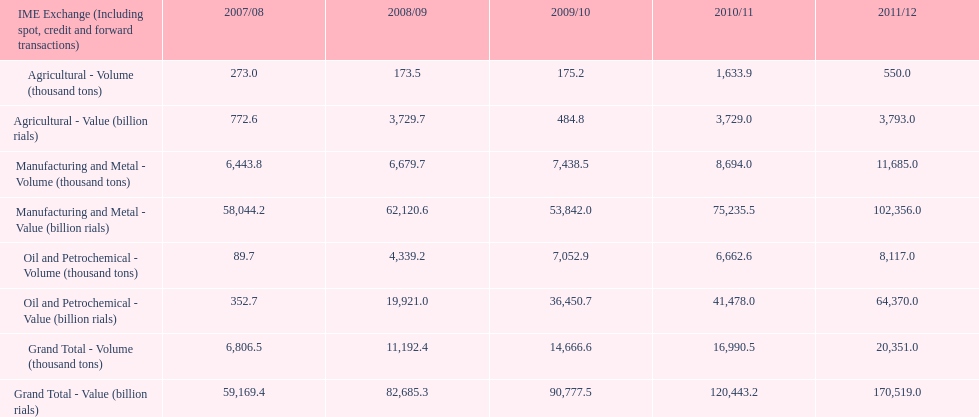What was the overall value of agriculture in the 2008/09 period? 3,729.7. 